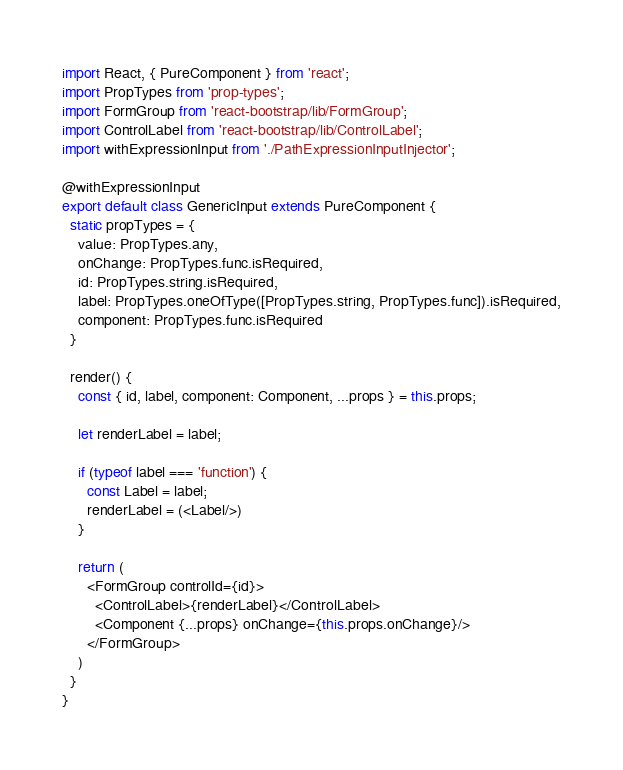<code> <loc_0><loc_0><loc_500><loc_500><_JavaScript_>import React, { PureComponent } from 'react';
import PropTypes from 'prop-types';
import FormGroup from 'react-bootstrap/lib/FormGroup';
import ControlLabel from 'react-bootstrap/lib/ControlLabel';
import withExpressionInput from './PathExpressionInputInjector';

@withExpressionInput
export default class GenericInput extends PureComponent {
  static propTypes = {
    value: PropTypes.any,
    onChange: PropTypes.func.isRequired,
    id: PropTypes.string.isRequired,
    label: PropTypes.oneOfType([PropTypes.string, PropTypes.func]).isRequired,
    component: PropTypes.func.isRequired
  }

  render() {
    const { id, label, component: Component, ...props } = this.props;

    let renderLabel = label;

    if (typeof label === 'function') {
      const Label = label;
      renderLabel = (<Label/>)
    }

    return (
      <FormGroup controlId={id}>
        <ControlLabel>{renderLabel}</ControlLabel>
        <Component {...props} onChange={this.props.onChange}/>
      </FormGroup>
    )
  }
}

</code> 